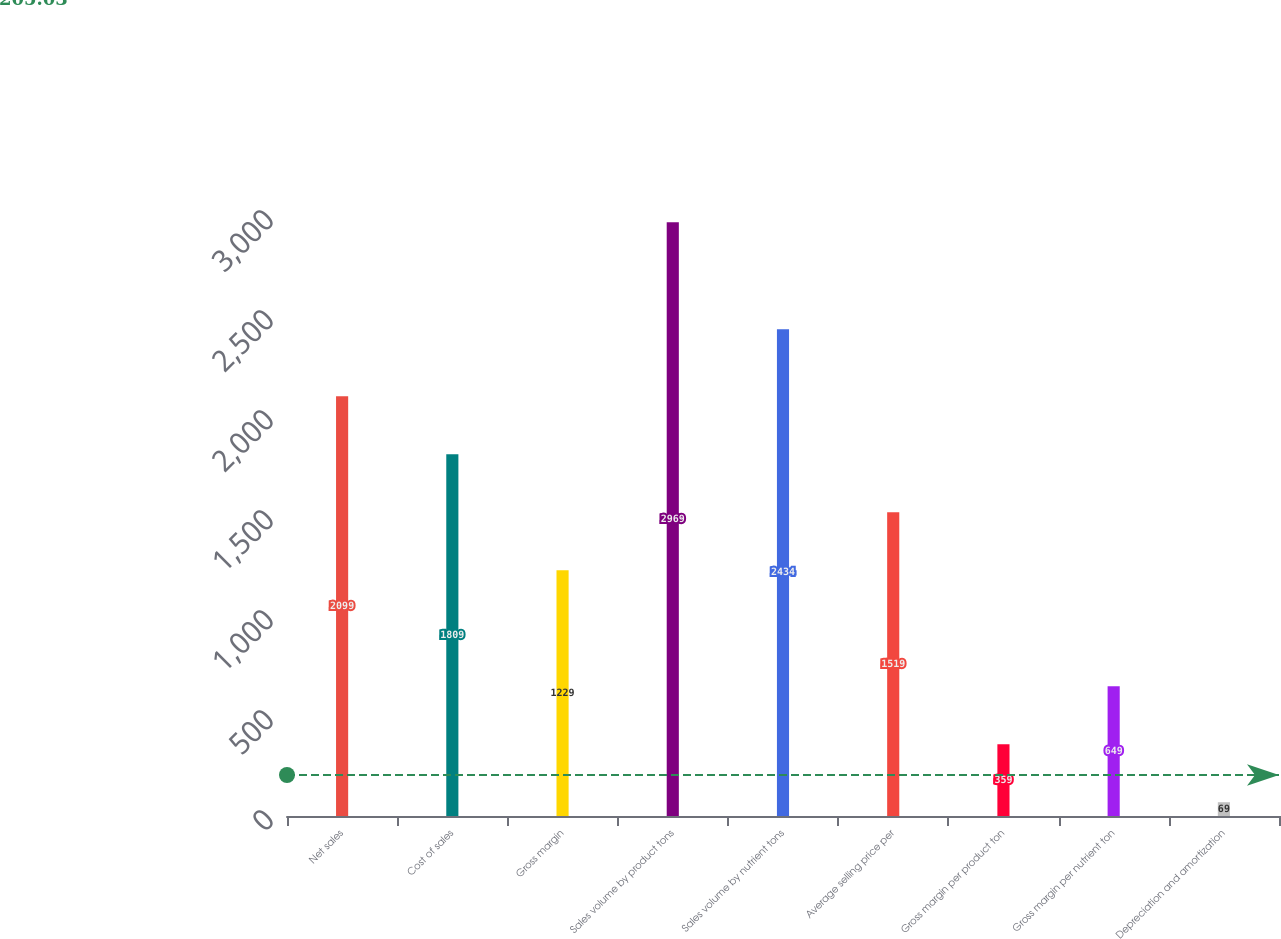Convert chart to OTSL. <chart><loc_0><loc_0><loc_500><loc_500><bar_chart><fcel>Net sales<fcel>Cost of sales<fcel>Gross margin<fcel>Sales volume by product tons<fcel>Sales volume by nutrient tons<fcel>Average selling price per<fcel>Gross margin per product ton<fcel>Gross margin per nutrient ton<fcel>Depreciation and amortization<nl><fcel>2099<fcel>1809<fcel>1229<fcel>2969<fcel>2434<fcel>1519<fcel>359<fcel>649<fcel>69<nl></chart> 